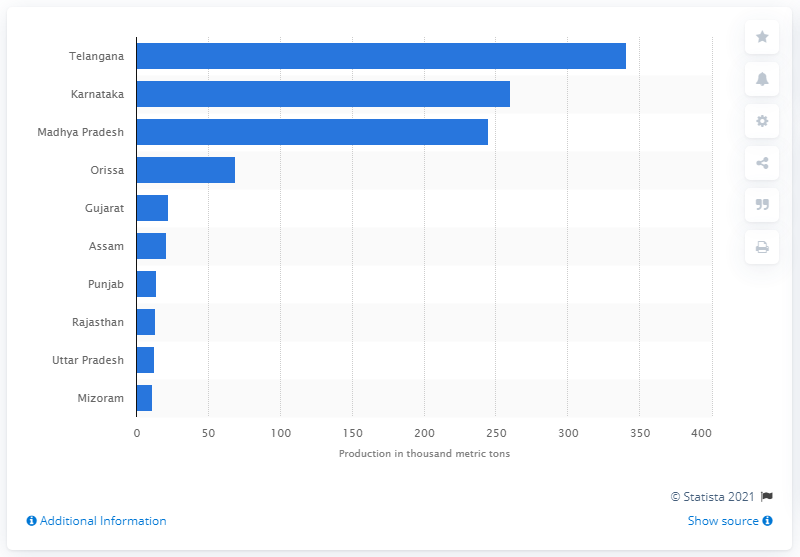Give some essential details in this illustration. Telangana was the largest producer of chilies in the fiscal year 2018. In 2018, Madhya Pradesh was the third largest producer of chilies in the state. 